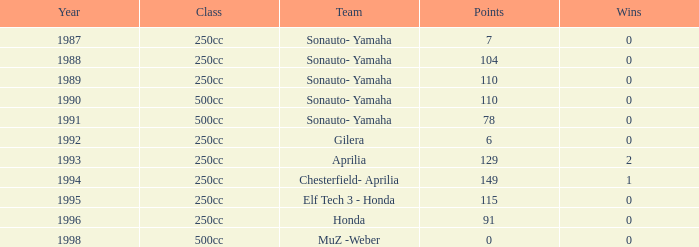What is the highest number of points the team with 0 wins had before 1992? 110.0. 